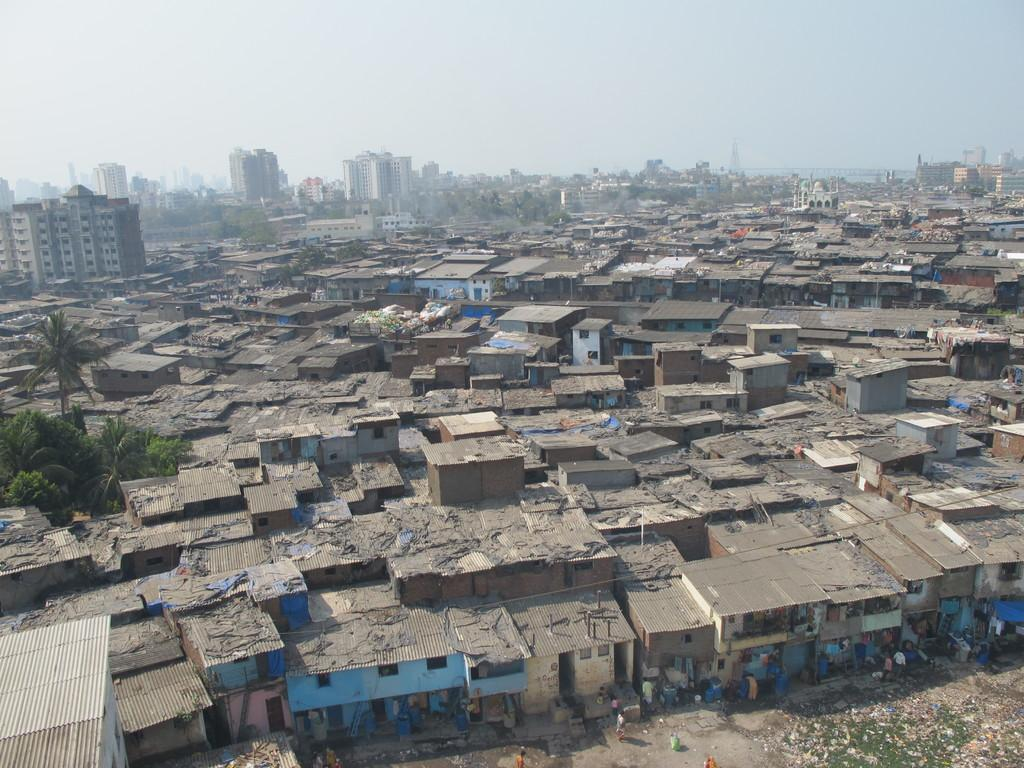What can be seen on the ground in the image? There are people on the ground in the image. What type of structures are visible in the image? There are buildings with windows in the image. What type of vegetation is present in the image? There are trees in the image. What is visible in the background of the image? The sky is visible in the background of the image. What type of record can be seen on the floor in the image? There is no record present in the image; it only features people, buildings, trees, and the sky. What is the head of the tree like in the image? There are no specific details about the heads of the trees in the image, as it only shows trees in general. 